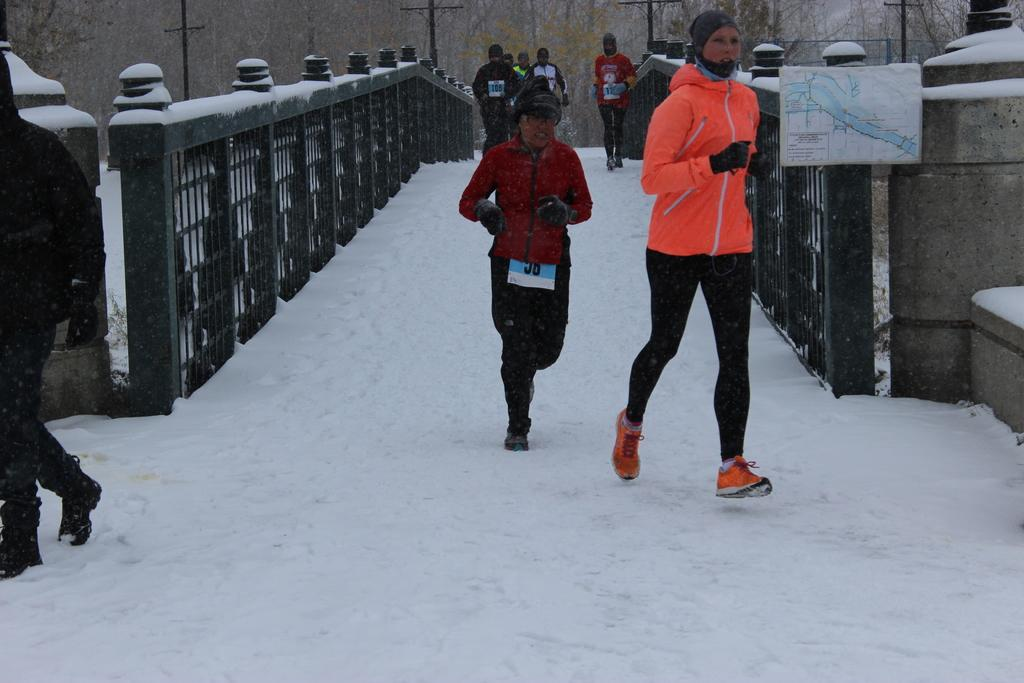How many people are in the image? There is a group of people in the image. What are the people doing in the image? The people are walking on the snow. What object can be seen in the image that might be used for navigation? There is a map in the image. What type of natural environment is visible in the background of the image? There are trees in the background of the image. What man-made structures can be seen in the background of the image? There are poles and a bridge in the background of the image. What type of soap is being used by the people in the image? There is no soap present in the image; the people are walking on snow. Can you tell me how many times the person in the front sneezes in the image? There is no indication of anyone sneezing in the image. 